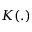Convert formula to latex. <formula><loc_0><loc_0><loc_500><loc_500>K ( . )</formula> 